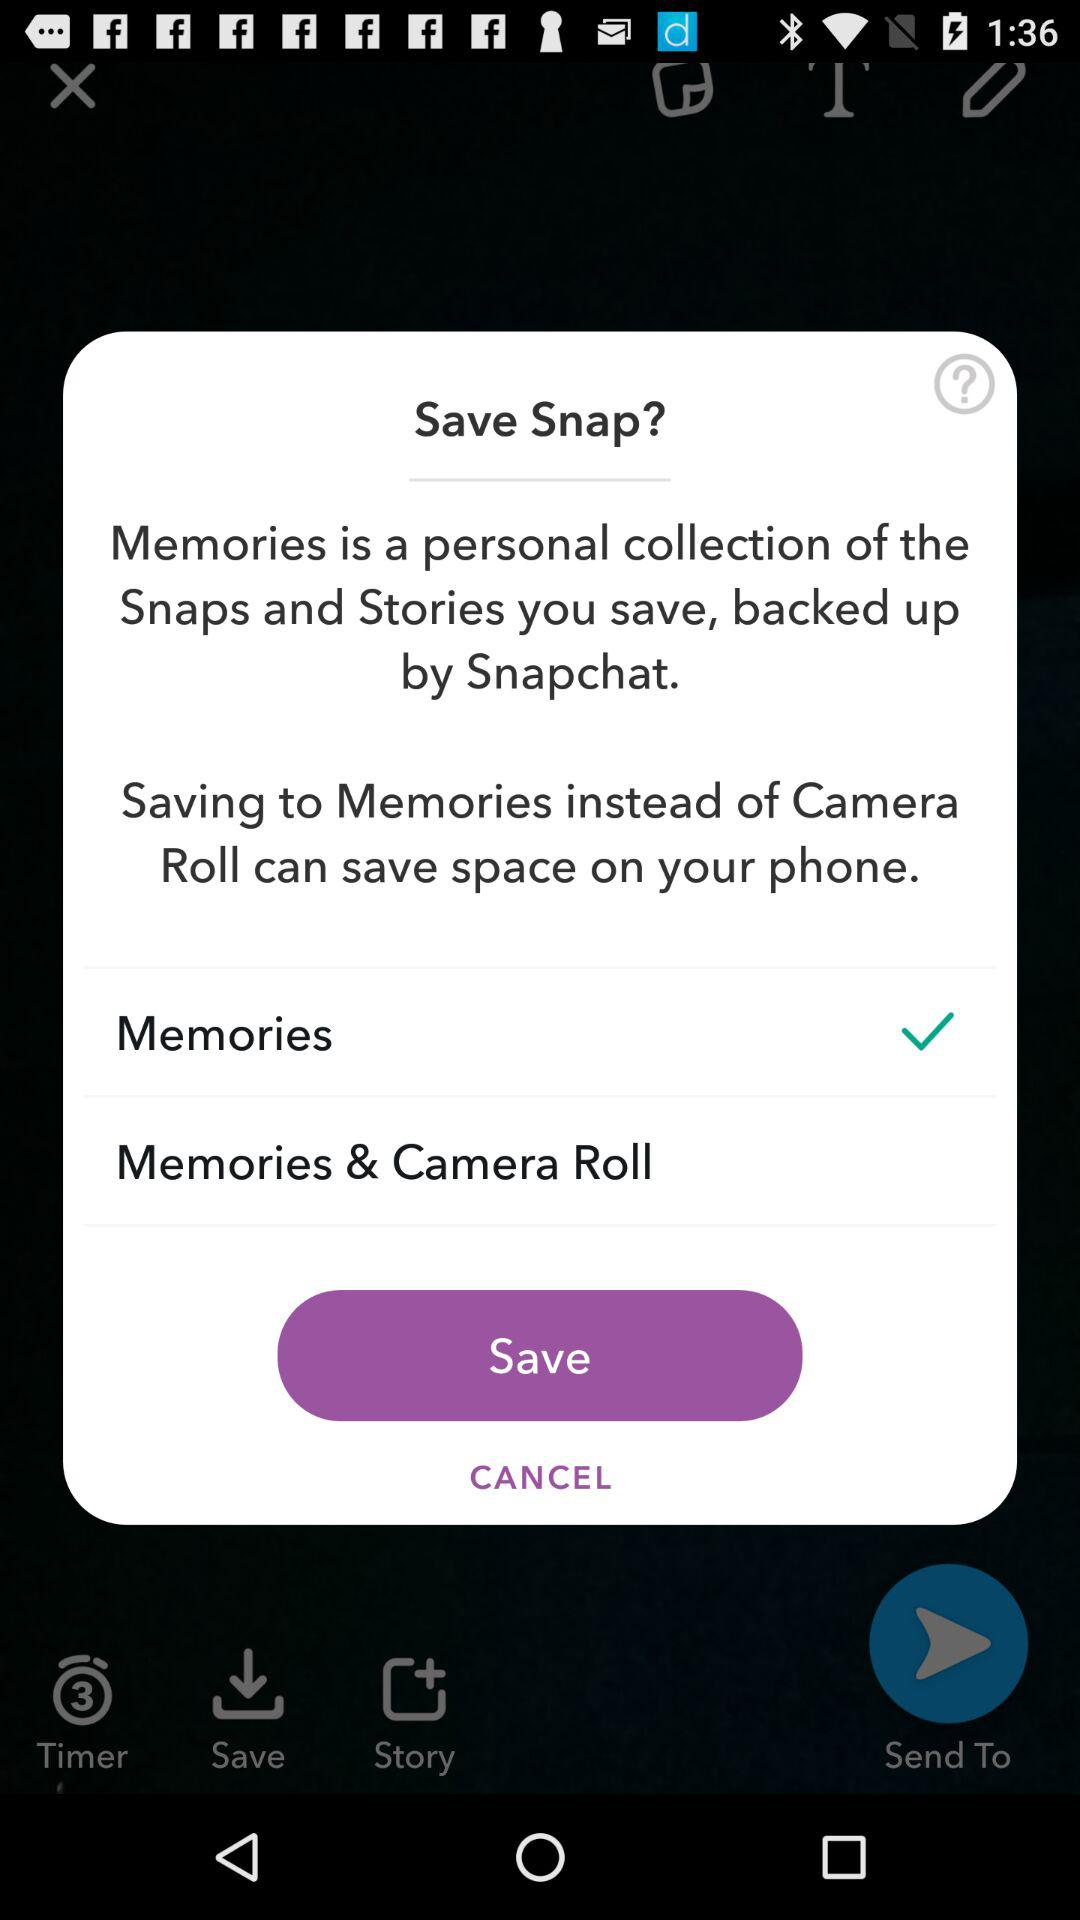What is the status of memories? The status is "on". 